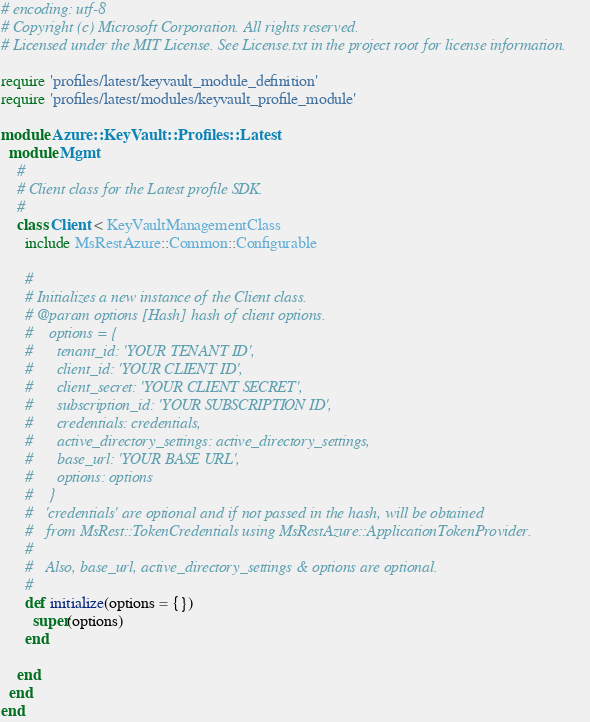Convert code to text. <code><loc_0><loc_0><loc_500><loc_500><_Ruby_># encoding: utf-8
# Copyright (c) Microsoft Corporation. All rights reserved.
# Licensed under the MIT License. See License.txt in the project root for license information.

require 'profiles/latest/keyvault_module_definition'
require 'profiles/latest/modules/keyvault_profile_module'

module Azure::KeyVault::Profiles::Latest
  module Mgmt
    #
    # Client class for the Latest profile SDK.
    #
    class Client < KeyVaultManagementClass
      include MsRestAzure::Common::Configurable

      #
      # Initializes a new instance of the Client class.
      # @param options [Hash] hash of client options.
      #    options = {
      #      tenant_id: 'YOUR TENANT ID',
      #      client_id: 'YOUR CLIENT ID',
      #      client_secret: 'YOUR CLIENT SECRET',
      #      subscription_id: 'YOUR SUBSCRIPTION ID',
      #      credentials: credentials,
      #      active_directory_settings: active_directory_settings,
      #      base_url: 'YOUR BASE URL',
      #      options: options
      #    }
      #   'credentials' are optional and if not passed in the hash, will be obtained
      #   from MsRest::TokenCredentials using MsRestAzure::ApplicationTokenProvider.
      #
      #   Also, base_url, active_directory_settings & options are optional.
      #
      def initialize(options = {})
        super(options)
      end

    end
  end
end
</code> 